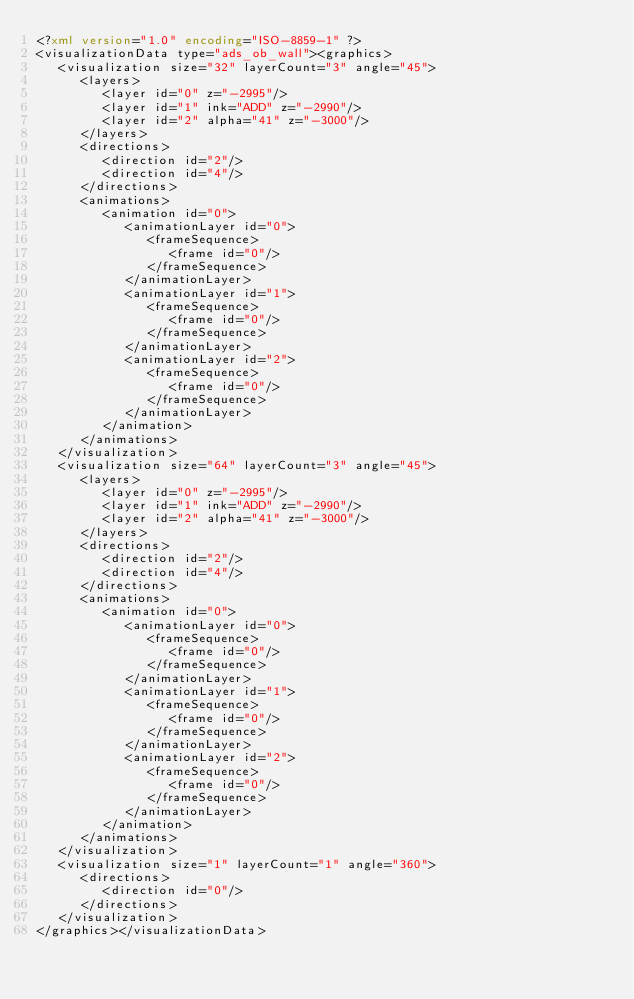Convert code to text. <code><loc_0><loc_0><loc_500><loc_500><_XML_><?xml version="1.0" encoding="ISO-8859-1" ?>
<visualizationData type="ads_ob_wall"><graphics>
   <visualization size="32" layerCount="3" angle="45">
      <layers>
         <layer id="0" z="-2995"/>
         <layer id="1" ink="ADD" z="-2990"/>
         <layer id="2" alpha="41" z="-3000"/>
      </layers>
      <directions>
         <direction id="2"/>
         <direction id="4"/>
      </directions>
      <animations>
         <animation id="0">
            <animationLayer id="0">
               <frameSequence>
                  <frame id="0"/>
               </frameSequence>
            </animationLayer>
            <animationLayer id="1">
               <frameSequence>
                  <frame id="0"/>
               </frameSequence>
            </animationLayer>
            <animationLayer id="2">
               <frameSequence>
                  <frame id="0"/>
               </frameSequence>
            </animationLayer>
         </animation>
      </animations>
   </visualization>
   <visualization size="64" layerCount="3" angle="45">
      <layers>
         <layer id="0" z="-2995"/>
         <layer id="1" ink="ADD" z="-2990"/>
         <layer id="2" alpha="41" z="-3000"/>
      </layers>
      <directions>
         <direction id="2"/>
         <direction id="4"/>
      </directions>
      <animations>
         <animation id="0">
            <animationLayer id="0">
               <frameSequence>
                  <frame id="0"/>
               </frameSequence>
            </animationLayer>
            <animationLayer id="1">
               <frameSequence>
                  <frame id="0"/>
               </frameSequence>
            </animationLayer>
            <animationLayer id="2">
               <frameSequence>
                  <frame id="0"/>
               </frameSequence>
            </animationLayer>
         </animation>
      </animations>
   </visualization>
   <visualization size="1" layerCount="1" angle="360">
      <directions>
         <direction id="0"/>
      </directions>
   </visualization>
</graphics></visualizationData>
</code> 